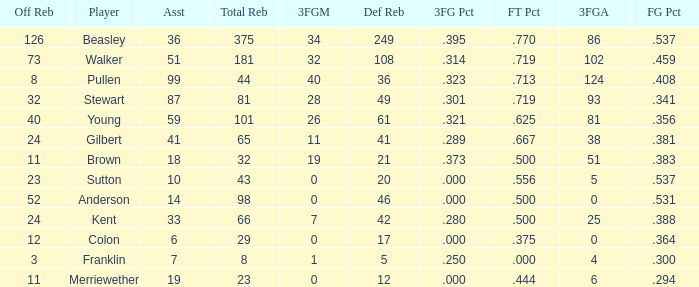Can you parse all the data within this table? {'header': ['Off Reb', 'Player', 'Asst', 'Total Reb', '3FGM', 'Def Reb', '3FG Pct', 'FT Pct', '3FGA', 'FG Pct'], 'rows': [['126', 'Beasley', '36', '375', '34', '249', '.395', '.770', '86', '.537'], ['73', 'Walker', '51', '181', '32', '108', '.314', '.719', '102', '.459'], ['8', 'Pullen', '99', '44', '40', '36', '.323', '.713', '124', '.408'], ['32', 'Stewart', '87', '81', '28', '49', '.301', '.719', '93', '.341'], ['40', 'Young', '59', '101', '26', '61', '.321', '.625', '81', '.356'], ['24', 'Gilbert', '41', '65', '11', '41', '.289', '.667', '38', '.381'], ['11', 'Brown', '18', '32', '19', '21', '.373', '.500', '51', '.383'], ['23', 'Sutton', '10', '43', '0', '20', '.000', '.556', '5', '.537'], ['52', 'Anderson', '14', '98', '0', '46', '.000', '.500', '0', '.531'], ['24', 'Kent', '33', '66', '7', '42', '.280', '.500', '25', '.388'], ['12', 'Colon', '6', '29', '0', '17', '.000', '.375', '0', '.364'], ['3', 'Franklin', '7', '8', '1', '5', '.250', '.000', '4', '.300'], ['11', 'Merriewether', '19', '23', '0', '12', '.000', '.444', '6', '.294']]} What is the total number of offensive rebounds for players with more than 124 3-point attempts? 0.0. 